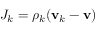<formula> <loc_0><loc_0><loc_500><loc_500>J _ { k } = \rho _ { k } ( v _ { k } - v )</formula> 